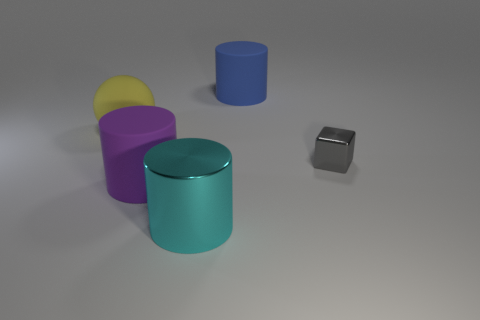There is a matte sphere that is the same size as the cyan cylinder; what is its color?
Offer a terse response. Yellow. What number of spheres are cyan metallic objects or big blue matte objects?
Keep it short and to the point. 0. Is the shape of the gray shiny thing the same as the metallic thing that is left of the big blue matte thing?
Offer a very short reply. No. How many cyan things have the same size as the yellow matte thing?
Offer a terse response. 1. There is a shiny thing behind the cyan cylinder; is it the same shape as the big matte thing in front of the tiny cube?
Your response must be concise. No. There is a shiny object on the left side of the large thing that is to the right of the cyan thing; what color is it?
Your answer should be compact. Cyan. What color is the other big shiny object that is the same shape as the big blue thing?
Offer a very short reply. Cyan. Are there any other things that have the same material as the large purple cylinder?
Provide a short and direct response. Yes. There is a cyan thing that is the same shape as the blue thing; what size is it?
Your answer should be compact. Large. What is the big cylinder in front of the purple rubber cylinder made of?
Offer a terse response. Metal. 